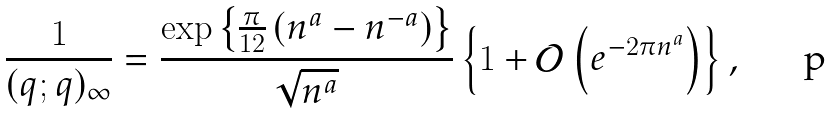<formula> <loc_0><loc_0><loc_500><loc_500>\frac { 1 } { ( q ; q ) _ { \infty } } = \frac { \exp \left \{ \frac { \pi } { 1 2 } \left ( n ^ { a } - n ^ { - a } \right ) \right \} } { \sqrt { n ^ { a } } } \left \{ 1 + \mathcal { O } \left ( e ^ { - 2 \pi n ^ { a } } \right ) \right \} ,</formula> 